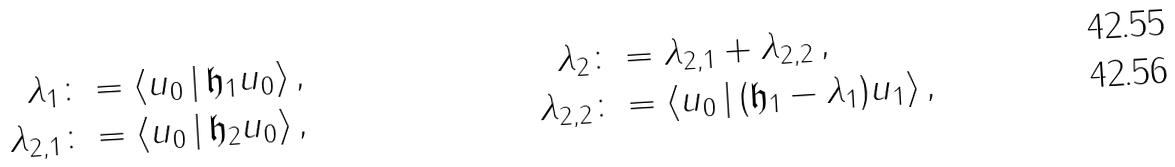<formula> <loc_0><loc_0><loc_500><loc_500>\lambda _ { 1 } & \colon = \langle u _ { 0 } \, | \, { \mathfrak h } _ { 1 } u _ { 0 } \rangle \, , & \lambda _ { 2 } & \colon = \lambda _ { 2 , 1 } + \lambda _ { 2 , 2 } \, , \\ \lambda _ { 2 , 1 } & \colon = \langle u _ { 0 } \, | \, { \mathfrak h } _ { 2 } u _ { 0 } \rangle \, , & \lambda _ { 2 , 2 } & \colon = \langle u _ { 0 } \, | \, ( { \mathfrak h } _ { 1 } - \lambda _ { 1 } ) u _ { 1 } \rangle \, ,</formula> 